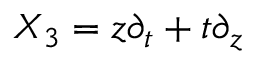Convert formula to latex. <formula><loc_0><loc_0><loc_500><loc_500>X _ { 3 } = z \partial _ { t } + t \partial _ { z } \,</formula> 